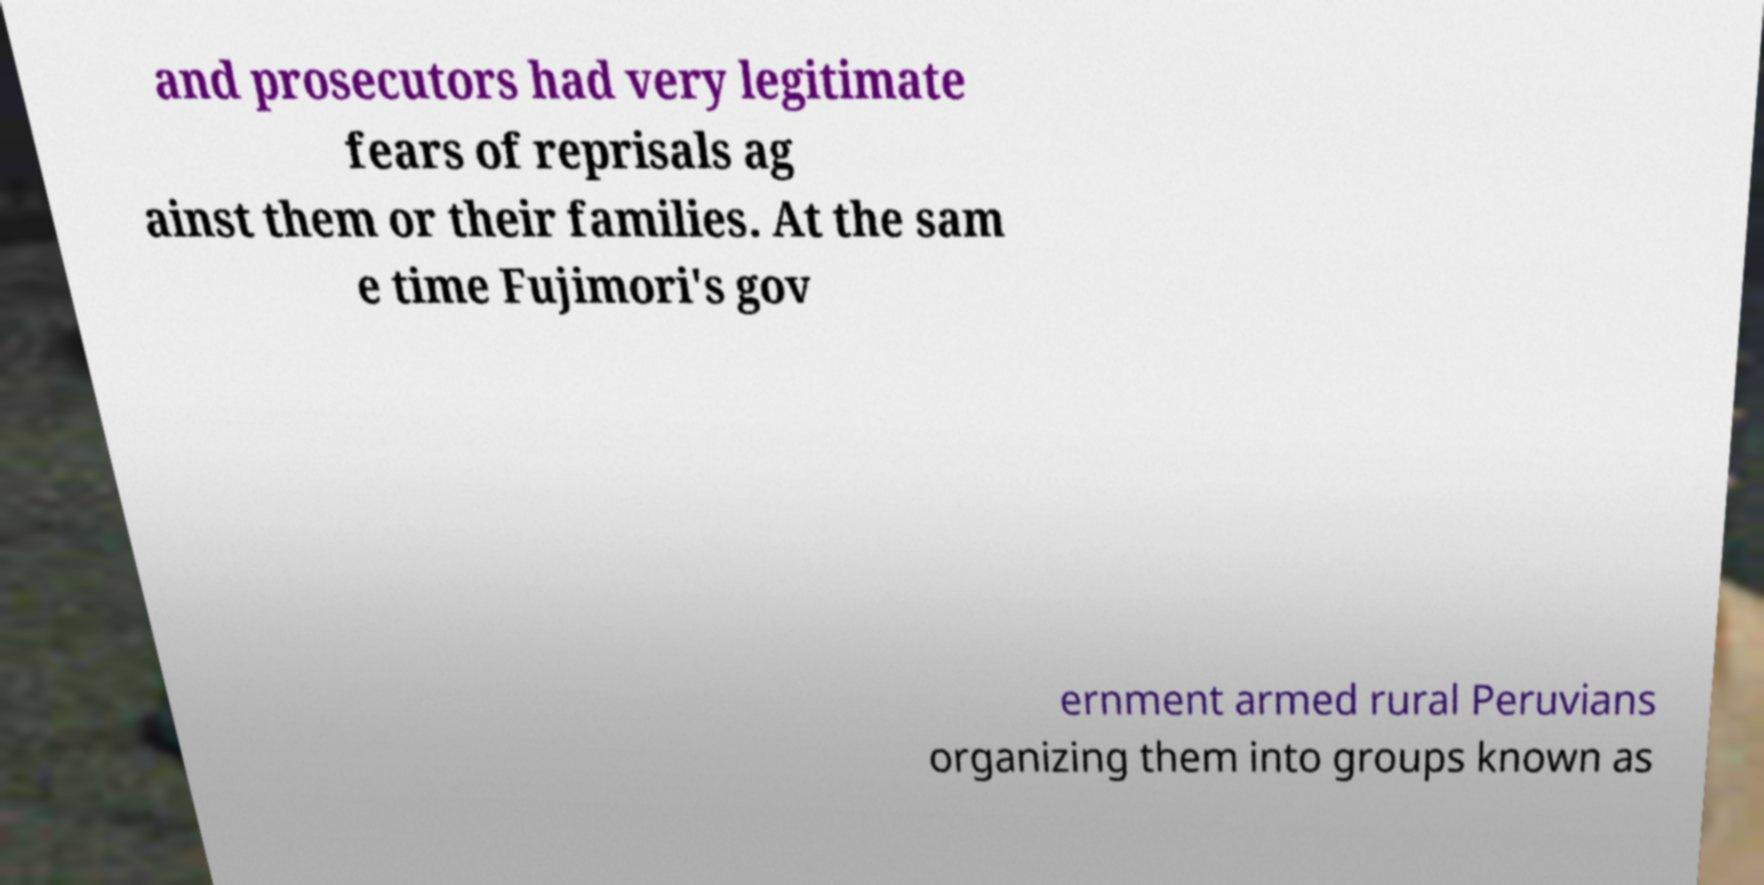What messages or text are displayed in this image? I need them in a readable, typed format. and prosecutors had very legitimate fears of reprisals ag ainst them or their families. At the sam e time Fujimori's gov ernment armed rural Peruvians organizing them into groups known as 